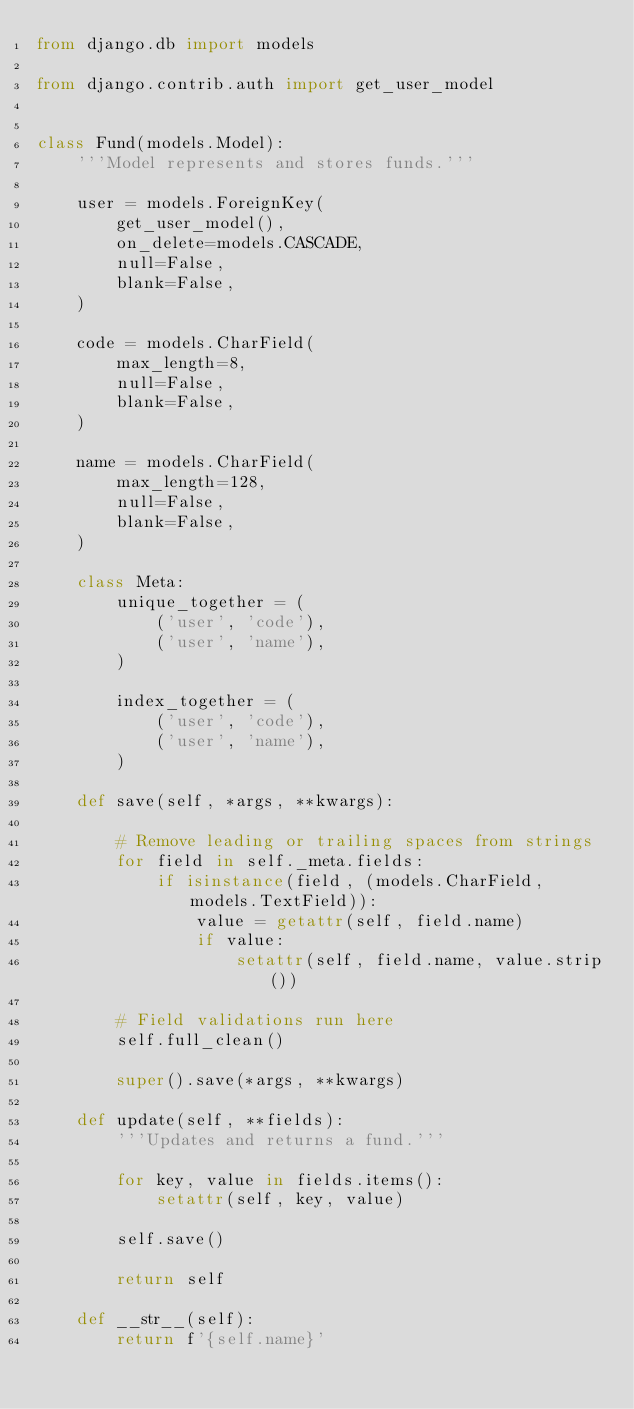<code> <loc_0><loc_0><loc_500><loc_500><_Python_>from django.db import models

from django.contrib.auth import get_user_model


class Fund(models.Model):
    '''Model represents and stores funds.'''

    user = models.ForeignKey(
        get_user_model(),
        on_delete=models.CASCADE,
        null=False,
        blank=False,
    )

    code = models.CharField(
        max_length=8,
        null=False,
        blank=False,
    )

    name = models.CharField(
        max_length=128,
        null=False,
        blank=False,
    )

    class Meta:
        unique_together = (
            ('user', 'code'),
            ('user', 'name'),
        )

        index_together = (
            ('user', 'code'),
            ('user', 'name'),
        )

    def save(self, *args, **kwargs):

        # Remove leading or trailing spaces from strings
        for field in self._meta.fields:
            if isinstance(field, (models.CharField, models.TextField)):
                value = getattr(self, field.name)
                if value:
                    setattr(self, field.name, value.strip())

        # Field validations run here
        self.full_clean()

        super().save(*args, **kwargs)

    def update(self, **fields):
        '''Updates and returns a fund.'''

        for key, value in fields.items():
            setattr(self, key, value)

        self.save()

        return self

    def __str__(self):
        return f'{self.name}'
</code> 